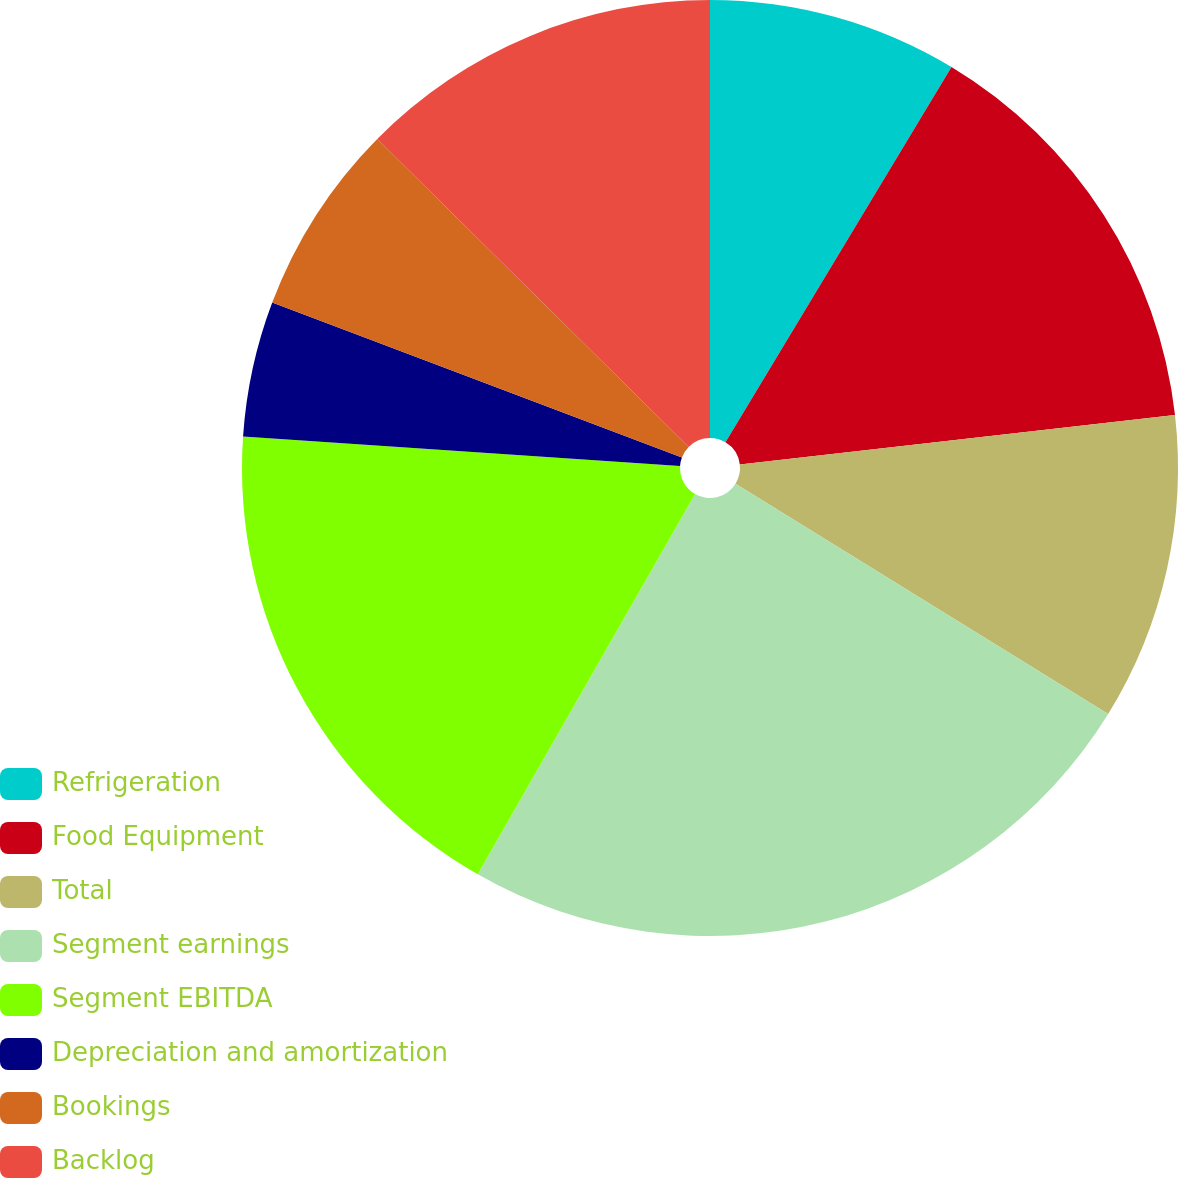Convert chart to OTSL. <chart><loc_0><loc_0><loc_500><loc_500><pie_chart><fcel>Refrigeration<fcel>Food Equipment<fcel>Total<fcel>Segment earnings<fcel>Segment EBITDA<fcel>Depreciation and amortization<fcel>Bookings<fcel>Backlog<nl><fcel>8.63%<fcel>14.57%<fcel>10.61%<fcel>24.46%<fcel>17.81%<fcel>4.68%<fcel>6.66%<fcel>12.59%<nl></chart> 